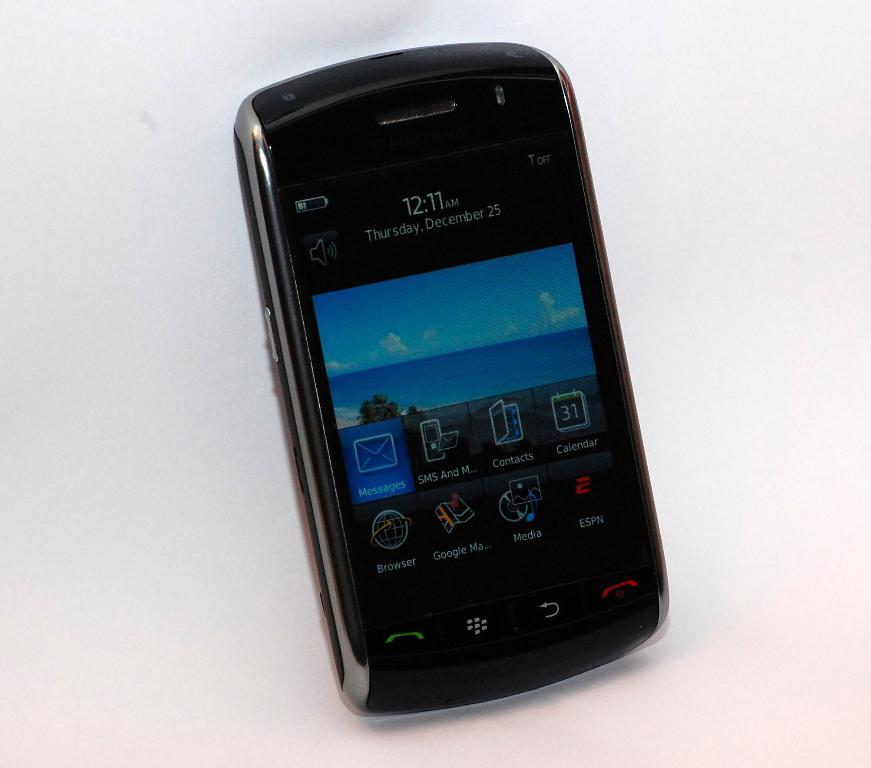What electronic device is visible in the image? There is a mobile phone in the image. What is the color of the mobile phone? The mobile phone is black in color. What type of pot is visible in the image? There is no pot present in the image. What kind of toys can be seen in the image? There are no toys present in the image. 